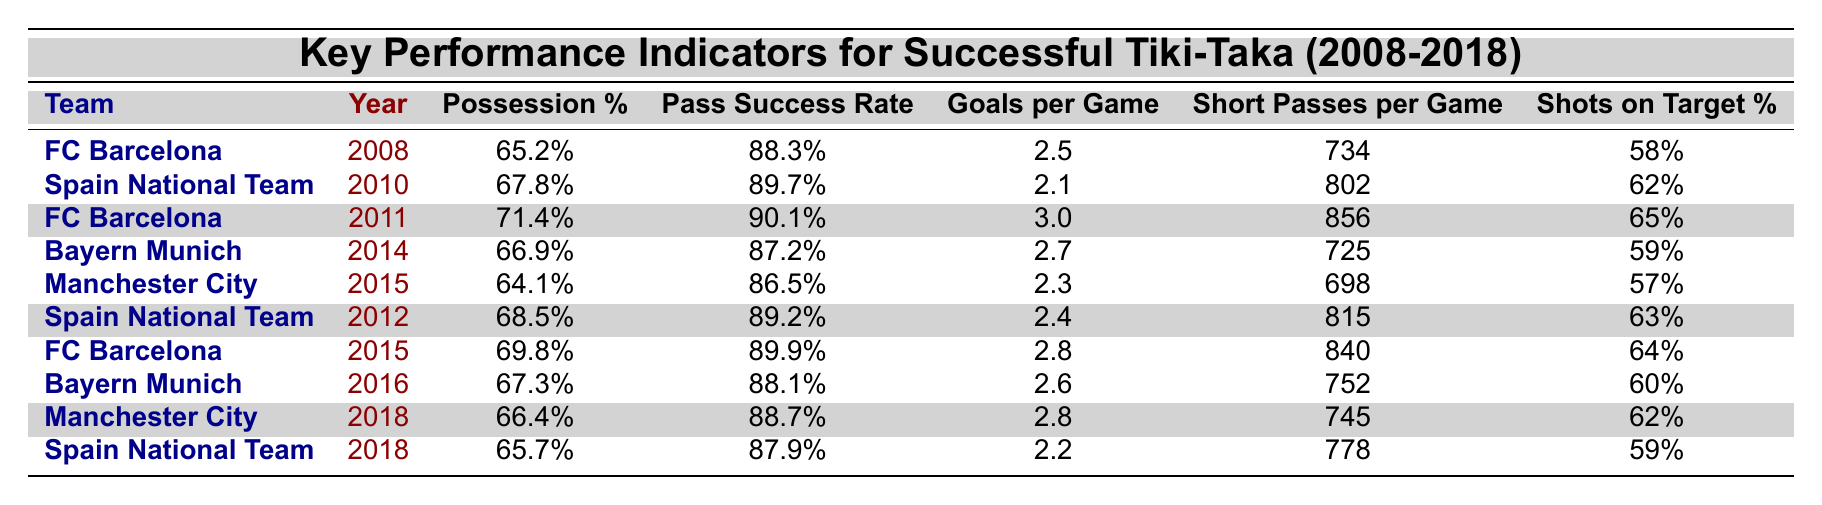What team had the highest possession percentage in the table? By examining the "Possession %" column in the table, FC Barcelona in 2011 shows the highest value at 71.4%.
Answer: FC Barcelona (2011) What year did Spain National Team achieve a possession percentage of 68.5%? Looking at the rows for the Spain National Team, the year corresponding to this possession percentage is 2012.
Answer: 2012 What is the average goals per game for FC Barcelona across all mentioned years? FC Barcelona has data for three years (2008: 2.5, 2011: 3.0, 2015: 2.8). The total is 2.5 + 3.0 + 2.8 = 8.3. Dividing by 3 gives an average of 8.3 / 3 = 2.77.
Answer: 2.77 Is it true that Bayern Munich had a pass success rate below 88% in 2014? Checking the "Pass Success Rate" for Bayern Munich in 2014, it is 87.2%, which is indeed below 88%.
Answer: Yes Which team had the best shots on target percentage in the dataset? By checking the "Shots on Target %" column, FC Barcelona in 2011 had the highest value at 65%.
Answer: FC Barcelona (2011) What is the difference in goals per game between FC Barcelona (2011) and Spain National Team (2010)? For FC Barcelona in 2011, the goals per game are 3.0, and for Spain National Team in 2010, it's 2.1. The difference is 3.0 - 2.1 = 0.9.
Answer: 0.9 Did Manchester City in 2015 have a higher pass success rate than Bayern Munich in 2016? By comparing the values, Manchester City in 2015 had a pass success rate of 86.5%, while Bayern Munich in 2016 had 88.1%. Hence, Manchester City had a lower pass success rate.
Answer: No What was the average possession percentage for the Spain National Team across the years listed? The possession percentages for Spain are (67.8% in 2010, 68.5% in 2012, and 65.7% in 2018). The total is 67.8 + 68.5 + 65.7 = 202. The average is 202 / 3 = 67.33%.
Answer: 67.33% 